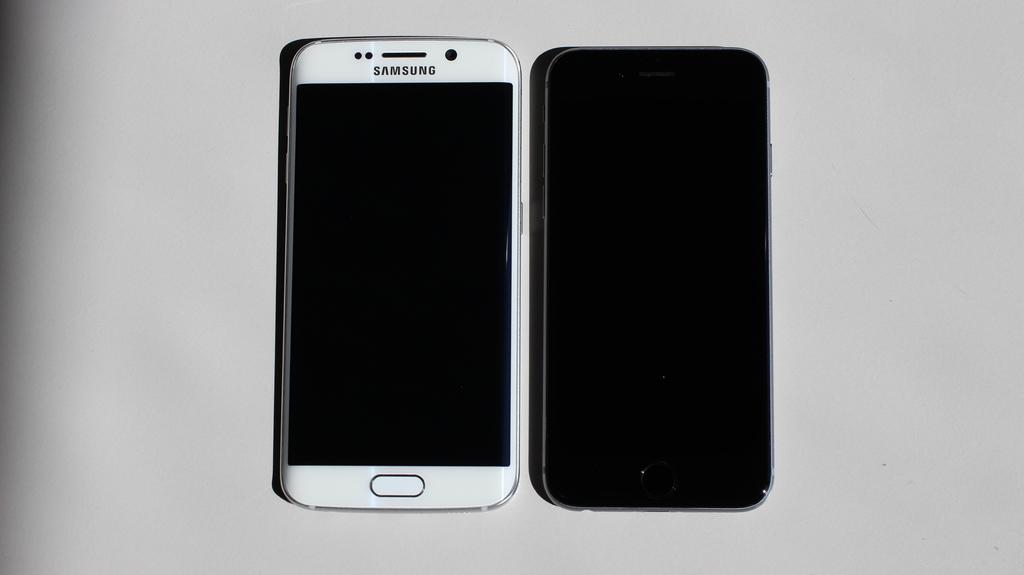<image>
Provide a brief description of the given image. Two phone, one of them white and a samsung. 